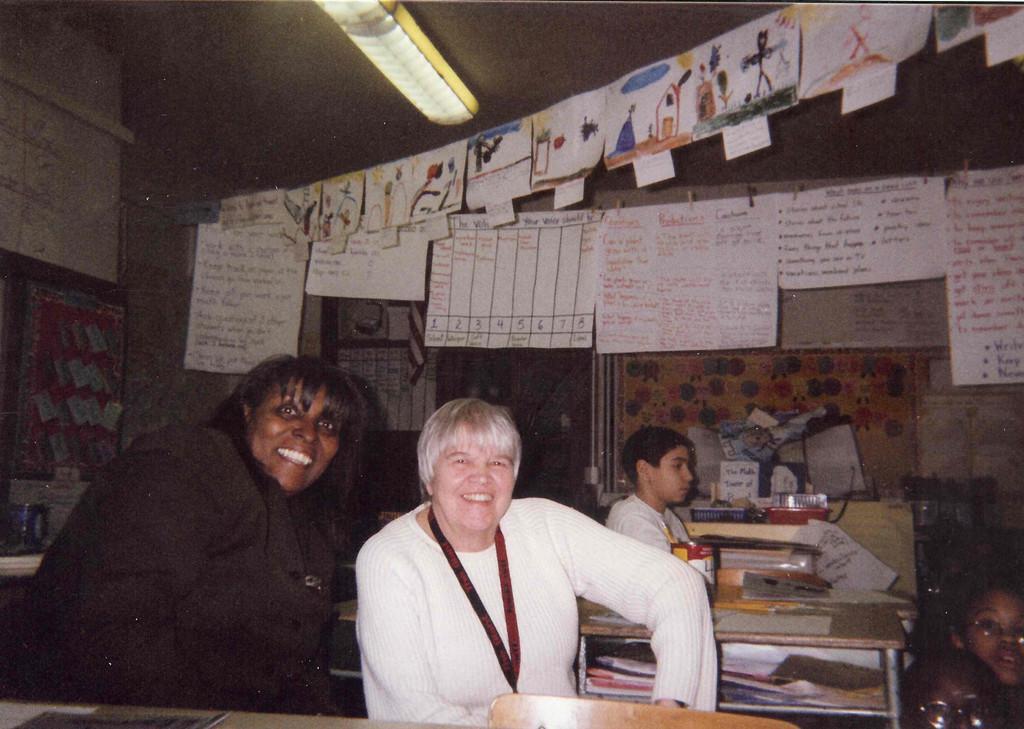Please provide a concise description of this image. In this image we can see a few people sitting, in front of them, we can see some tables, on the tables, there are some papers, trays, tin and some other objects, we can see some posters with text and images on it and also there are some posters on the wall, at the top we can see a light. 